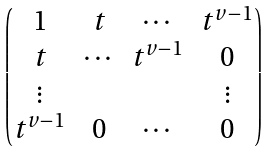<formula> <loc_0><loc_0><loc_500><loc_500>\begin{pmatrix} 1 & t & \cdots & t ^ { v - 1 } \\ t & \cdots & t ^ { v - 1 } & 0 \\ \vdots & & & \vdots \\ t ^ { v - 1 } & 0 & \cdots & 0 \end{pmatrix}</formula> 